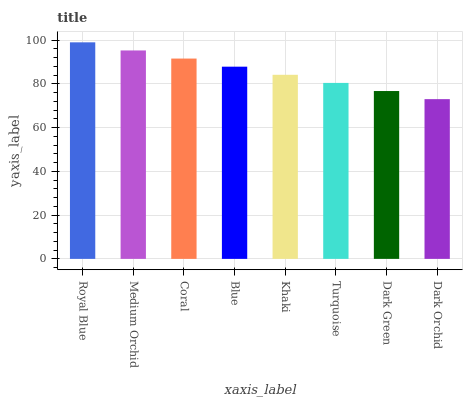Is Dark Orchid the minimum?
Answer yes or no. Yes. Is Royal Blue the maximum?
Answer yes or no. Yes. Is Medium Orchid the minimum?
Answer yes or no. No. Is Medium Orchid the maximum?
Answer yes or no. No. Is Royal Blue greater than Medium Orchid?
Answer yes or no. Yes. Is Medium Orchid less than Royal Blue?
Answer yes or no. Yes. Is Medium Orchid greater than Royal Blue?
Answer yes or no. No. Is Royal Blue less than Medium Orchid?
Answer yes or no. No. Is Blue the high median?
Answer yes or no. Yes. Is Khaki the low median?
Answer yes or no. Yes. Is Khaki the high median?
Answer yes or no. No. Is Royal Blue the low median?
Answer yes or no. No. 